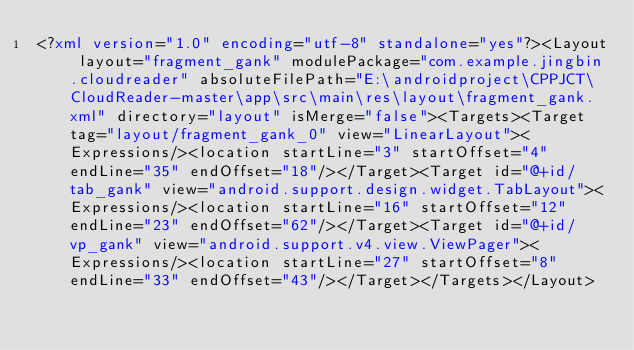Convert code to text. <code><loc_0><loc_0><loc_500><loc_500><_XML_><?xml version="1.0" encoding="utf-8" standalone="yes"?><Layout layout="fragment_gank" modulePackage="com.example.jingbin.cloudreader" absoluteFilePath="E:\androidproject\CPPJCT\CloudReader-master\app\src\main\res\layout\fragment_gank.xml" directory="layout" isMerge="false"><Targets><Target tag="layout/fragment_gank_0" view="LinearLayout"><Expressions/><location startLine="3" startOffset="4" endLine="35" endOffset="18"/></Target><Target id="@+id/tab_gank" view="android.support.design.widget.TabLayout"><Expressions/><location startLine="16" startOffset="12" endLine="23" endOffset="62"/></Target><Target id="@+id/vp_gank" view="android.support.v4.view.ViewPager"><Expressions/><location startLine="27" startOffset="8" endLine="33" endOffset="43"/></Target></Targets></Layout></code> 